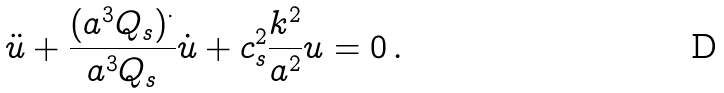Convert formula to latex. <formula><loc_0><loc_0><loc_500><loc_500>\ddot { u } + \frac { ( a ^ { 3 } Q _ { s } ) ^ { \cdot } } { a ^ { 3 } Q _ { s } } \dot { u } + c _ { s } ^ { 2 } \frac { k ^ { 2 } } { a ^ { 2 } } u = 0 \, .</formula> 